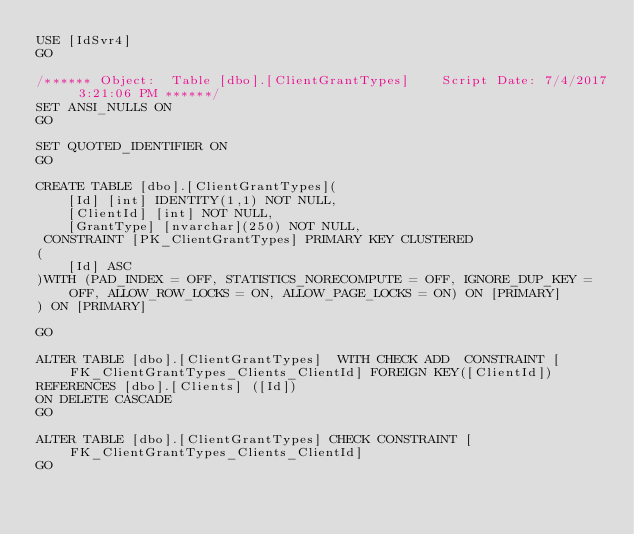<code> <loc_0><loc_0><loc_500><loc_500><_SQL_>USE [IdSvr4]
GO

/****** Object:  Table [dbo].[ClientGrantTypes]    Script Date: 7/4/2017 3:21:06 PM ******/
SET ANSI_NULLS ON
GO

SET QUOTED_IDENTIFIER ON
GO

CREATE TABLE [dbo].[ClientGrantTypes](
	[Id] [int] IDENTITY(1,1) NOT NULL,
	[ClientId] [int] NOT NULL,
	[GrantType] [nvarchar](250) NOT NULL,
 CONSTRAINT [PK_ClientGrantTypes] PRIMARY KEY CLUSTERED 
(
	[Id] ASC
)WITH (PAD_INDEX = OFF, STATISTICS_NORECOMPUTE = OFF, IGNORE_DUP_KEY = OFF, ALLOW_ROW_LOCKS = ON, ALLOW_PAGE_LOCKS = ON) ON [PRIMARY]
) ON [PRIMARY]

GO

ALTER TABLE [dbo].[ClientGrantTypes]  WITH CHECK ADD  CONSTRAINT [FK_ClientGrantTypes_Clients_ClientId] FOREIGN KEY([ClientId])
REFERENCES [dbo].[Clients] ([Id])
ON DELETE CASCADE
GO

ALTER TABLE [dbo].[ClientGrantTypes] CHECK CONSTRAINT [FK_ClientGrantTypes_Clients_ClientId]
GO


</code> 